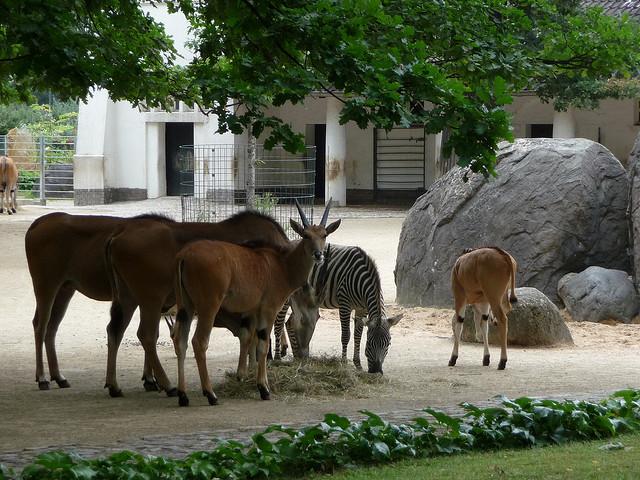Do the animals have hooves?
Be succinct. Yes. Where is this picture take?
Keep it brief. Zoo. How many animals are there pictured?
Give a very brief answer. 5. 